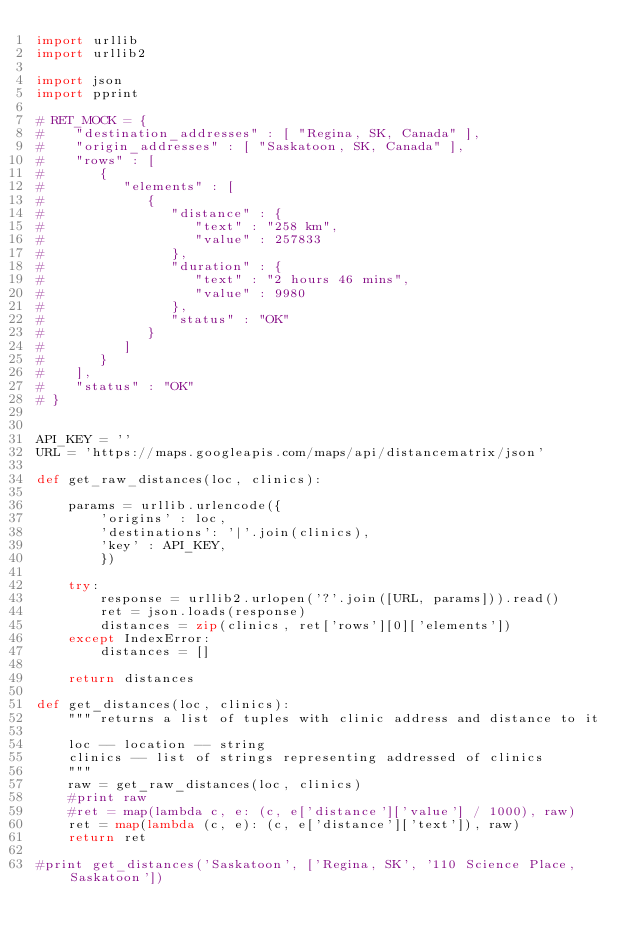Convert code to text. <code><loc_0><loc_0><loc_500><loc_500><_Python_>import urllib
import urllib2

import json
import pprint

# RET_MOCK = {
#    "destination_addresses" : [ "Regina, SK, Canada" ],
#    "origin_addresses" : [ "Saskatoon, SK, Canada" ],
#    "rows" : [
#       {
#          "elements" : [
#             {
#                "distance" : {
#                   "text" : "258 km",
#                   "value" : 257833
#                },
#                "duration" : {
#                   "text" : "2 hours 46 mins",
#                   "value" : 9980
#                },
#                "status" : "OK"
#             }
#          ]
#       }
#    ],
#    "status" : "OK"
# }


API_KEY = ''
URL = 'https://maps.googleapis.com/maps/api/distancematrix/json'

def get_raw_distances(loc, clinics):

    params = urllib.urlencode({ 
        'origins' : loc,
        'destinations': '|'.join(clinics),
        'key' : API_KEY,
        })

    try:
        response = urllib2.urlopen('?'.join([URL, params])).read()
        ret = json.loads(response)
        distances = zip(clinics, ret['rows'][0]['elements'])
    except IndexError:
        distances = []

    return distances

def get_distances(loc, clinics):
    """ returns a list of tuples with clinic address and distance to it

    loc -- location -- string
    clinics -- list of strings representing addressed of clinics
    """
    raw = get_raw_distances(loc, clinics)
    #print raw
    #ret = map(lambda c, e: (c, e['distance']['value'] / 1000), raw)
    ret = map(lambda (c, e): (c, e['distance']['text']), raw)
    return ret

#print get_distances('Saskatoon', ['Regina, SK', '110 Science Place, Saskatoon'])

</code> 